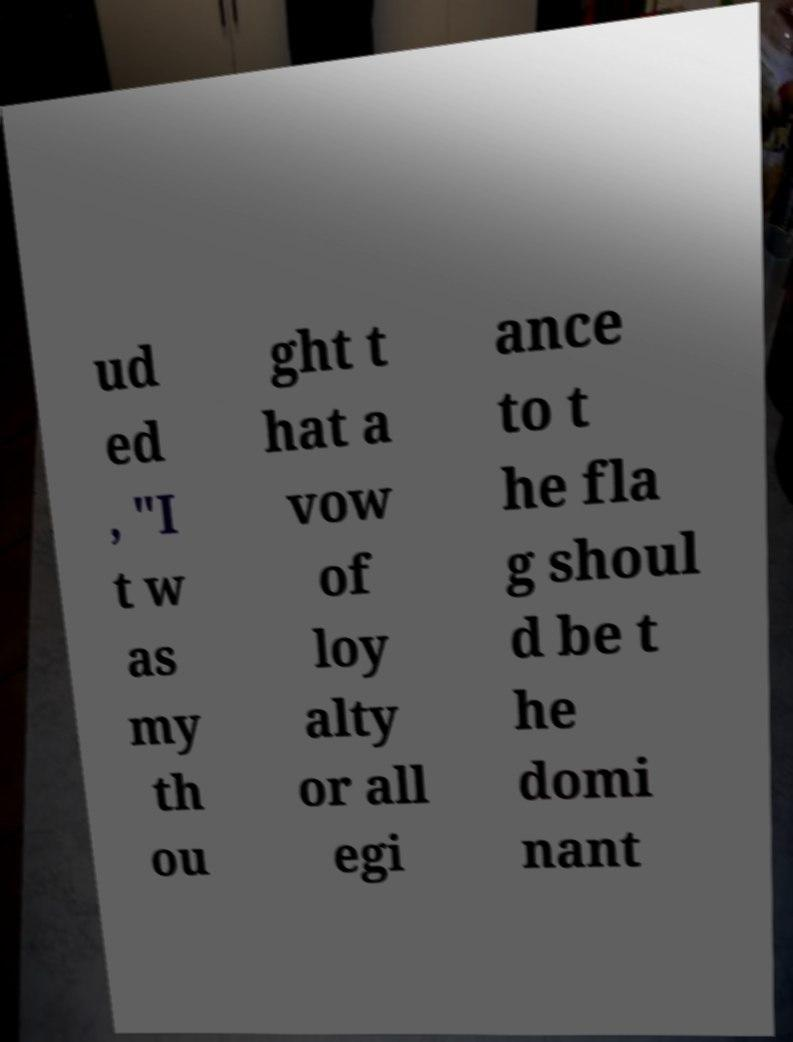For documentation purposes, I need the text within this image transcribed. Could you provide that? ud ed , "I t w as my th ou ght t hat a vow of loy alty or all egi ance to t he fla g shoul d be t he domi nant 